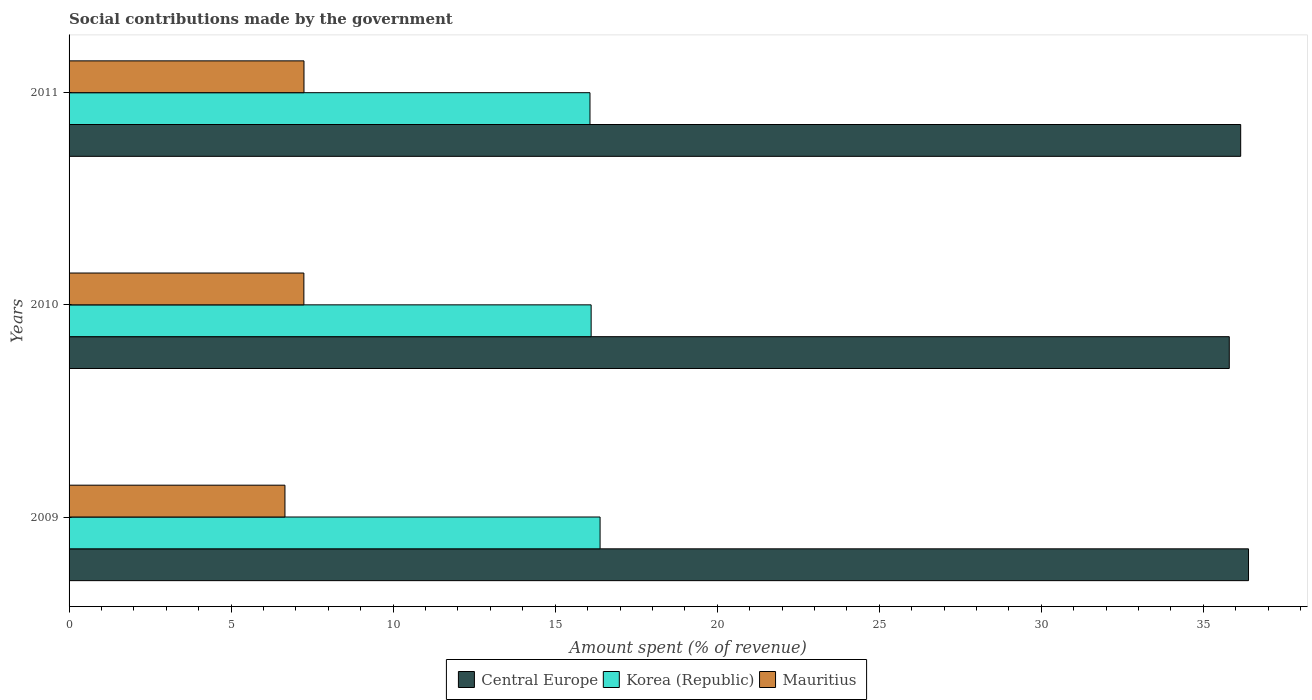Are the number of bars per tick equal to the number of legend labels?
Give a very brief answer. Yes. Are the number of bars on each tick of the Y-axis equal?
Provide a short and direct response. Yes. In how many cases, is the number of bars for a given year not equal to the number of legend labels?
Keep it short and to the point. 0. What is the amount spent (in %) on social contributions in Central Europe in 2009?
Offer a terse response. 36.39. Across all years, what is the maximum amount spent (in %) on social contributions in Mauritius?
Provide a succinct answer. 7.25. Across all years, what is the minimum amount spent (in %) on social contributions in Korea (Republic)?
Your response must be concise. 16.07. In which year was the amount spent (in %) on social contributions in Mauritius maximum?
Your response must be concise. 2011. In which year was the amount spent (in %) on social contributions in Korea (Republic) minimum?
Offer a very short reply. 2011. What is the total amount spent (in %) on social contributions in Korea (Republic) in the graph?
Offer a very short reply. 48.57. What is the difference between the amount spent (in %) on social contributions in Mauritius in 2009 and that in 2010?
Make the answer very short. -0.58. What is the difference between the amount spent (in %) on social contributions in Mauritius in 2009 and the amount spent (in %) on social contributions in Korea (Republic) in 2011?
Your response must be concise. -9.41. What is the average amount spent (in %) on social contributions in Central Europe per year?
Keep it short and to the point. 36.11. In the year 2010, what is the difference between the amount spent (in %) on social contributions in Mauritius and amount spent (in %) on social contributions in Central Europe?
Ensure brevity in your answer.  -28.55. In how many years, is the amount spent (in %) on social contributions in Korea (Republic) greater than 30 %?
Ensure brevity in your answer.  0. What is the ratio of the amount spent (in %) on social contributions in Mauritius in 2010 to that in 2011?
Your response must be concise. 1. Is the difference between the amount spent (in %) on social contributions in Mauritius in 2009 and 2010 greater than the difference between the amount spent (in %) on social contributions in Central Europe in 2009 and 2010?
Your answer should be very brief. No. What is the difference between the highest and the second highest amount spent (in %) on social contributions in Korea (Republic)?
Keep it short and to the point. 0.28. What is the difference between the highest and the lowest amount spent (in %) on social contributions in Central Europe?
Give a very brief answer. 0.59. In how many years, is the amount spent (in %) on social contributions in Mauritius greater than the average amount spent (in %) on social contributions in Mauritius taken over all years?
Keep it short and to the point. 2. Is the sum of the amount spent (in %) on social contributions in Central Europe in 2010 and 2011 greater than the maximum amount spent (in %) on social contributions in Mauritius across all years?
Provide a succinct answer. Yes. What does the 2nd bar from the top in 2011 represents?
Offer a very short reply. Korea (Republic). How many bars are there?
Provide a succinct answer. 9. What is the difference between two consecutive major ticks on the X-axis?
Ensure brevity in your answer.  5. Are the values on the major ticks of X-axis written in scientific E-notation?
Ensure brevity in your answer.  No. Does the graph contain grids?
Give a very brief answer. No. Where does the legend appear in the graph?
Ensure brevity in your answer.  Bottom center. What is the title of the graph?
Provide a short and direct response. Social contributions made by the government. What is the label or title of the X-axis?
Provide a succinct answer. Amount spent (% of revenue). What is the Amount spent (% of revenue) of Central Europe in 2009?
Make the answer very short. 36.39. What is the Amount spent (% of revenue) in Korea (Republic) in 2009?
Make the answer very short. 16.38. What is the Amount spent (% of revenue) in Mauritius in 2009?
Make the answer very short. 6.66. What is the Amount spent (% of revenue) of Central Europe in 2010?
Provide a short and direct response. 35.8. What is the Amount spent (% of revenue) of Korea (Republic) in 2010?
Your answer should be compact. 16.11. What is the Amount spent (% of revenue) of Mauritius in 2010?
Your answer should be very brief. 7.24. What is the Amount spent (% of revenue) of Central Europe in 2011?
Your answer should be very brief. 36.15. What is the Amount spent (% of revenue) in Korea (Republic) in 2011?
Your response must be concise. 16.07. What is the Amount spent (% of revenue) of Mauritius in 2011?
Your answer should be compact. 7.25. Across all years, what is the maximum Amount spent (% of revenue) in Central Europe?
Your answer should be compact. 36.39. Across all years, what is the maximum Amount spent (% of revenue) in Korea (Republic)?
Offer a terse response. 16.38. Across all years, what is the maximum Amount spent (% of revenue) in Mauritius?
Make the answer very short. 7.25. Across all years, what is the minimum Amount spent (% of revenue) of Central Europe?
Make the answer very short. 35.8. Across all years, what is the minimum Amount spent (% of revenue) in Korea (Republic)?
Ensure brevity in your answer.  16.07. Across all years, what is the minimum Amount spent (% of revenue) in Mauritius?
Offer a very short reply. 6.66. What is the total Amount spent (% of revenue) of Central Europe in the graph?
Your response must be concise. 108.34. What is the total Amount spent (% of revenue) in Korea (Republic) in the graph?
Offer a very short reply. 48.57. What is the total Amount spent (% of revenue) of Mauritius in the graph?
Make the answer very short. 21.15. What is the difference between the Amount spent (% of revenue) in Central Europe in 2009 and that in 2010?
Your answer should be very brief. 0.59. What is the difference between the Amount spent (% of revenue) in Korea (Republic) in 2009 and that in 2010?
Your answer should be compact. 0.28. What is the difference between the Amount spent (% of revenue) of Mauritius in 2009 and that in 2010?
Provide a short and direct response. -0.58. What is the difference between the Amount spent (% of revenue) of Central Europe in 2009 and that in 2011?
Your answer should be compact. 0.24. What is the difference between the Amount spent (% of revenue) in Korea (Republic) in 2009 and that in 2011?
Your response must be concise. 0.31. What is the difference between the Amount spent (% of revenue) in Mauritius in 2009 and that in 2011?
Ensure brevity in your answer.  -0.59. What is the difference between the Amount spent (% of revenue) in Central Europe in 2010 and that in 2011?
Provide a succinct answer. -0.35. What is the difference between the Amount spent (% of revenue) of Korea (Republic) in 2010 and that in 2011?
Offer a terse response. 0.04. What is the difference between the Amount spent (% of revenue) of Mauritius in 2010 and that in 2011?
Your answer should be very brief. -0. What is the difference between the Amount spent (% of revenue) of Central Europe in 2009 and the Amount spent (% of revenue) of Korea (Republic) in 2010?
Give a very brief answer. 20.28. What is the difference between the Amount spent (% of revenue) of Central Europe in 2009 and the Amount spent (% of revenue) of Mauritius in 2010?
Provide a short and direct response. 29.15. What is the difference between the Amount spent (% of revenue) of Korea (Republic) in 2009 and the Amount spent (% of revenue) of Mauritius in 2010?
Offer a very short reply. 9.14. What is the difference between the Amount spent (% of revenue) of Central Europe in 2009 and the Amount spent (% of revenue) of Korea (Republic) in 2011?
Your answer should be very brief. 20.32. What is the difference between the Amount spent (% of revenue) of Central Europe in 2009 and the Amount spent (% of revenue) of Mauritius in 2011?
Offer a terse response. 29.14. What is the difference between the Amount spent (% of revenue) in Korea (Republic) in 2009 and the Amount spent (% of revenue) in Mauritius in 2011?
Give a very brief answer. 9.14. What is the difference between the Amount spent (% of revenue) of Central Europe in 2010 and the Amount spent (% of revenue) of Korea (Republic) in 2011?
Your response must be concise. 19.73. What is the difference between the Amount spent (% of revenue) in Central Europe in 2010 and the Amount spent (% of revenue) in Mauritius in 2011?
Make the answer very short. 28.55. What is the difference between the Amount spent (% of revenue) of Korea (Republic) in 2010 and the Amount spent (% of revenue) of Mauritius in 2011?
Ensure brevity in your answer.  8.86. What is the average Amount spent (% of revenue) of Central Europe per year?
Your answer should be very brief. 36.11. What is the average Amount spent (% of revenue) of Korea (Republic) per year?
Your answer should be very brief. 16.19. What is the average Amount spent (% of revenue) in Mauritius per year?
Make the answer very short. 7.05. In the year 2009, what is the difference between the Amount spent (% of revenue) of Central Europe and Amount spent (% of revenue) of Korea (Republic)?
Provide a succinct answer. 20.01. In the year 2009, what is the difference between the Amount spent (% of revenue) of Central Europe and Amount spent (% of revenue) of Mauritius?
Keep it short and to the point. 29.73. In the year 2009, what is the difference between the Amount spent (% of revenue) in Korea (Republic) and Amount spent (% of revenue) in Mauritius?
Keep it short and to the point. 9.72. In the year 2010, what is the difference between the Amount spent (% of revenue) of Central Europe and Amount spent (% of revenue) of Korea (Republic)?
Make the answer very short. 19.69. In the year 2010, what is the difference between the Amount spent (% of revenue) of Central Europe and Amount spent (% of revenue) of Mauritius?
Ensure brevity in your answer.  28.55. In the year 2010, what is the difference between the Amount spent (% of revenue) of Korea (Republic) and Amount spent (% of revenue) of Mauritius?
Your answer should be very brief. 8.86. In the year 2011, what is the difference between the Amount spent (% of revenue) in Central Europe and Amount spent (% of revenue) in Korea (Republic)?
Provide a succinct answer. 20.08. In the year 2011, what is the difference between the Amount spent (% of revenue) in Central Europe and Amount spent (% of revenue) in Mauritius?
Your answer should be compact. 28.9. In the year 2011, what is the difference between the Amount spent (% of revenue) of Korea (Republic) and Amount spent (% of revenue) of Mauritius?
Give a very brief answer. 8.82. What is the ratio of the Amount spent (% of revenue) in Central Europe in 2009 to that in 2010?
Make the answer very short. 1.02. What is the ratio of the Amount spent (% of revenue) in Korea (Republic) in 2009 to that in 2010?
Provide a succinct answer. 1.02. What is the ratio of the Amount spent (% of revenue) of Mauritius in 2009 to that in 2010?
Offer a terse response. 0.92. What is the ratio of the Amount spent (% of revenue) of Central Europe in 2009 to that in 2011?
Your answer should be compact. 1.01. What is the ratio of the Amount spent (% of revenue) of Korea (Republic) in 2009 to that in 2011?
Your answer should be very brief. 1.02. What is the ratio of the Amount spent (% of revenue) of Mauritius in 2009 to that in 2011?
Offer a very short reply. 0.92. What is the ratio of the Amount spent (% of revenue) of Central Europe in 2010 to that in 2011?
Provide a short and direct response. 0.99. What is the difference between the highest and the second highest Amount spent (% of revenue) of Central Europe?
Provide a short and direct response. 0.24. What is the difference between the highest and the second highest Amount spent (% of revenue) in Korea (Republic)?
Your response must be concise. 0.28. What is the difference between the highest and the second highest Amount spent (% of revenue) of Mauritius?
Provide a succinct answer. 0. What is the difference between the highest and the lowest Amount spent (% of revenue) of Central Europe?
Your answer should be compact. 0.59. What is the difference between the highest and the lowest Amount spent (% of revenue) of Korea (Republic)?
Your answer should be very brief. 0.31. What is the difference between the highest and the lowest Amount spent (% of revenue) in Mauritius?
Your response must be concise. 0.59. 